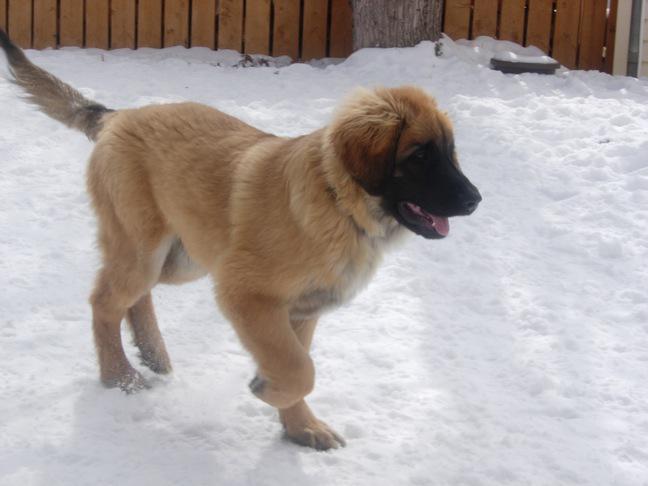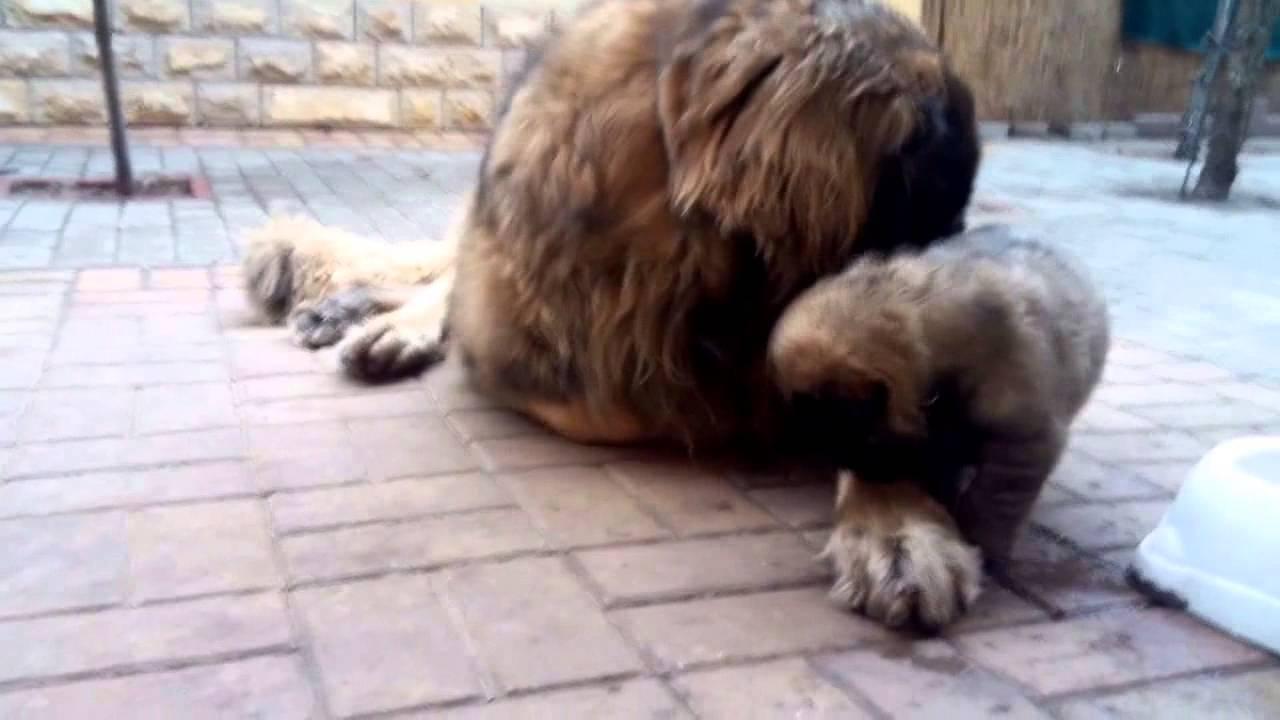The first image is the image on the left, the second image is the image on the right. Considering the images on both sides, is "An image shows at least one puppy on a stone-type floor with a pattern that includes square shapes." valid? Answer yes or no. Yes. The first image is the image on the left, the second image is the image on the right. Analyze the images presented: Is the assertion "A single dog is standing on a white surface in one of the images." valid? Answer yes or no. Yes. 